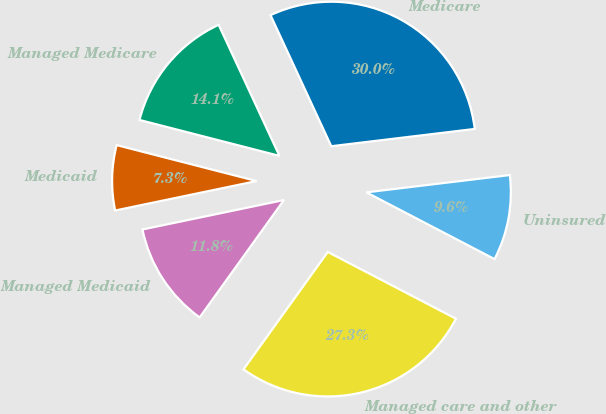Convert chart to OTSL. <chart><loc_0><loc_0><loc_500><loc_500><pie_chart><fcel>Medicare<fcel>Managed Medicare<fcel>Medicaid<fcel>Managed Medicaid<fcel>Managed care and other<fcel>Uninsured<nl><fcel>30.0%<fcel>14.09%<fcel>7.27%<fcel>11.82%<fcel>27.27%<fcel>9.55%<nl></chart> 